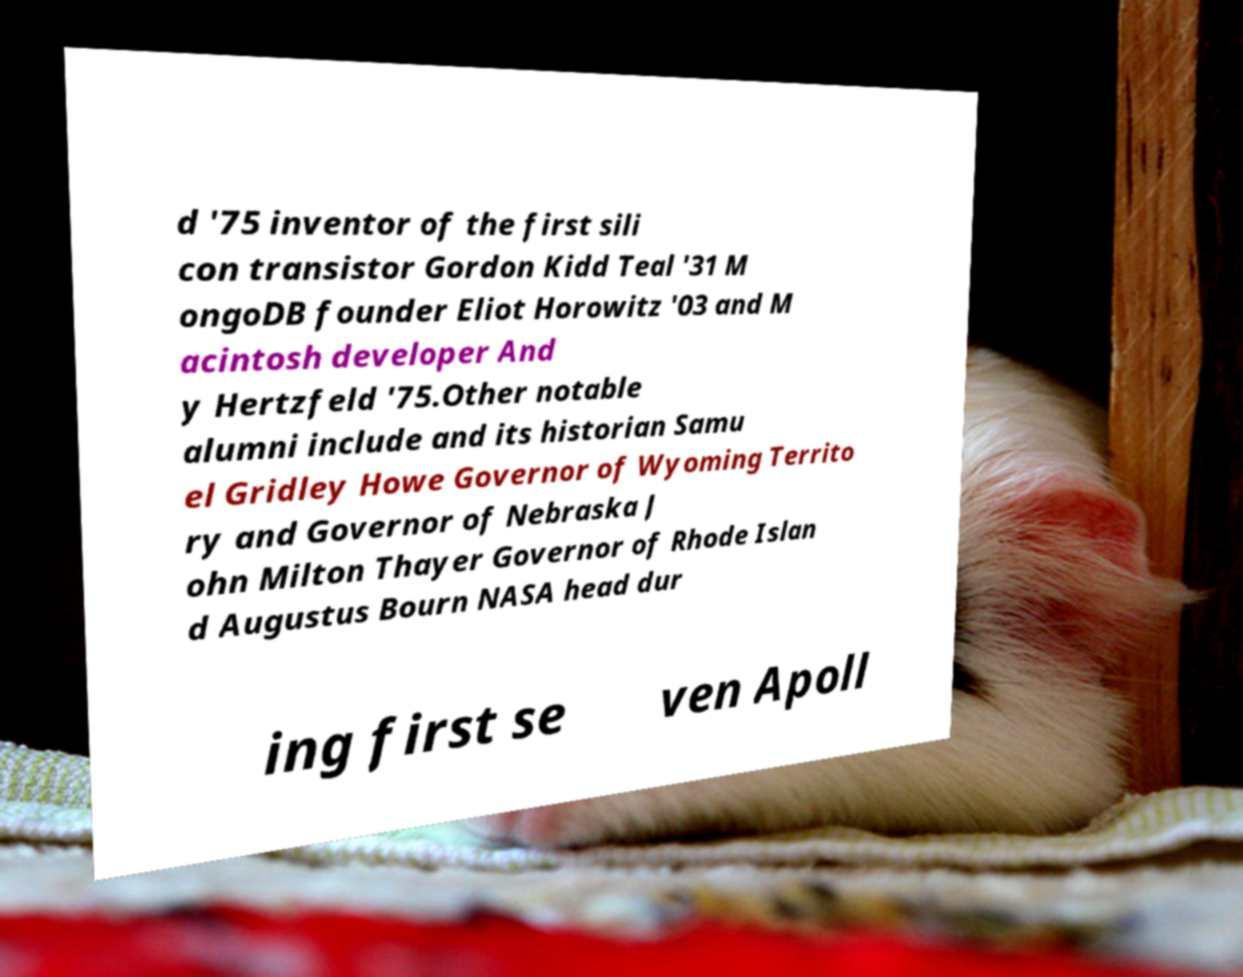Could you extract and type out the text from this image? d '75 inventor of the first sili con transistor Gordon Kidd Teal '31 M ongoDB founder Eliot Horowitz '03 and M acintosh developer And y Hertzfeld '75.Other notable alumni include and its historian Samu el Gridley Howe Governor of Wyoming Territo ry and Governor of Nebraska J ohn Milton Thayer Governor of Rhode Islan d Augustus Bourn NASA head dur ing first se ven Apoll 